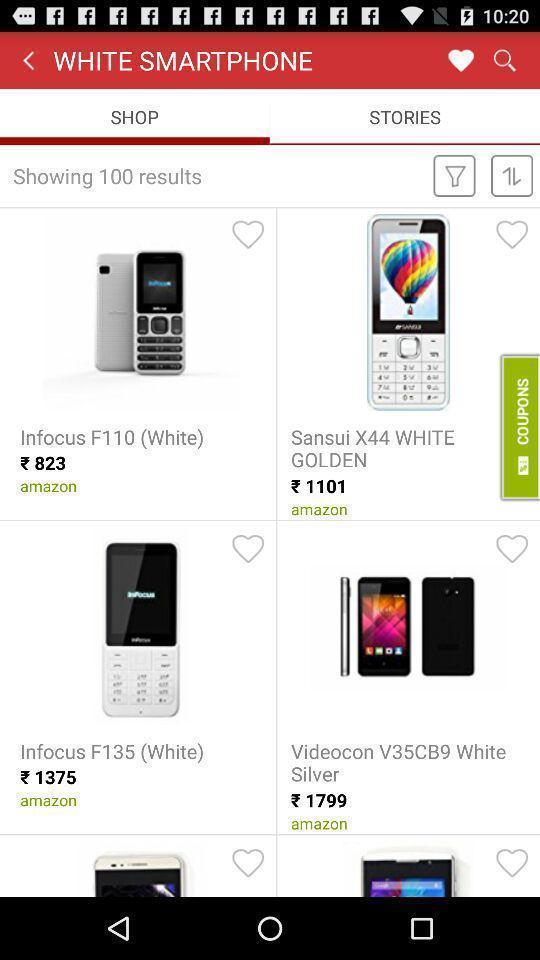What details can you identify in this image? Screen shows mobiles in a shopping app. 